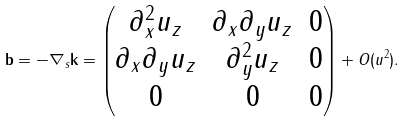<formula> <loc_0><loc_0><loc_500><loc_500>\mathbf b = - \nabla _ { s } \mathbf k = \begin{pmatrix} \partial _ { x } ^ { 2 } u _ { z } & \partial _ { x } \partial _ { y } u _ { z } & 0 \\ \partial _ { x } \partial _ { y } u _ { z } & \partial _ { y } ^ { 2 } u _ { z } & 0 \\ 0 & 0 & 0 \end{pmatrix} + O ( u ^ { 2 } ) .</formula> 